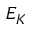<formula> <loc_0><loc_0><loc_500><loc_500>E _ { K }</formula> 